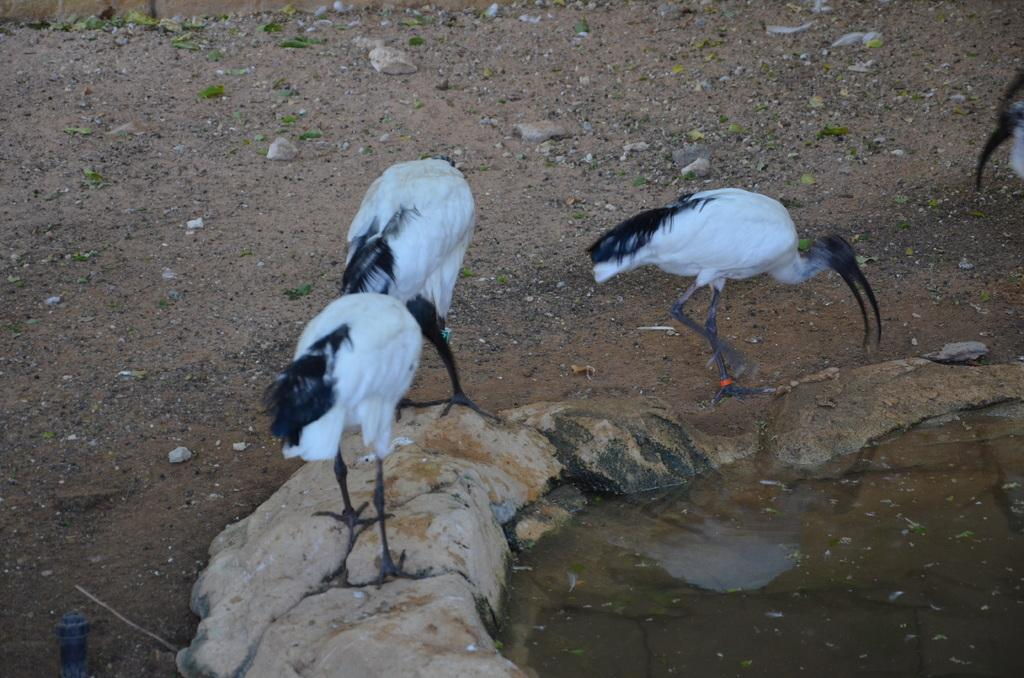What type of animals can be seen in the image? There are birds in the image. Can you describe the color of the birds? The birds are white and black in color. What is the primary element in which the birds are situated? There is water visible in the image, and the birds are situated in it. What other elements can be seen in the image? There are stones and sand in the image. What type of corn can be seen growing in the image? There is no corn present in the image; it features birds in water with stones and sand. 